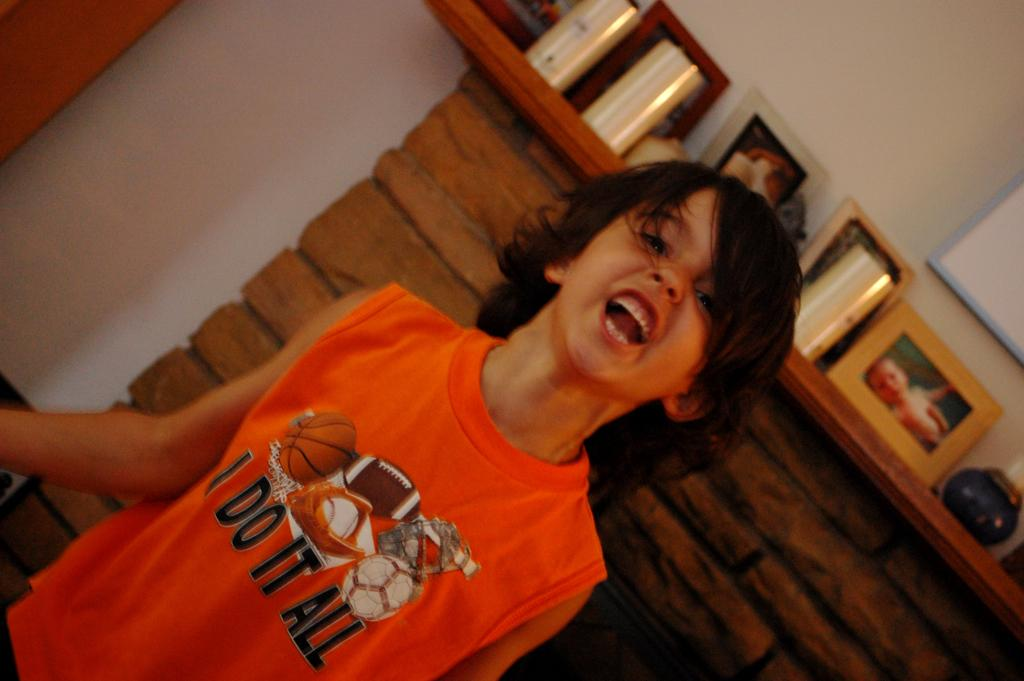<image>
Share a concise interpretation of the image provided. Little boy standing in front of a fireplace yelling wearing a I do it all shirt. 